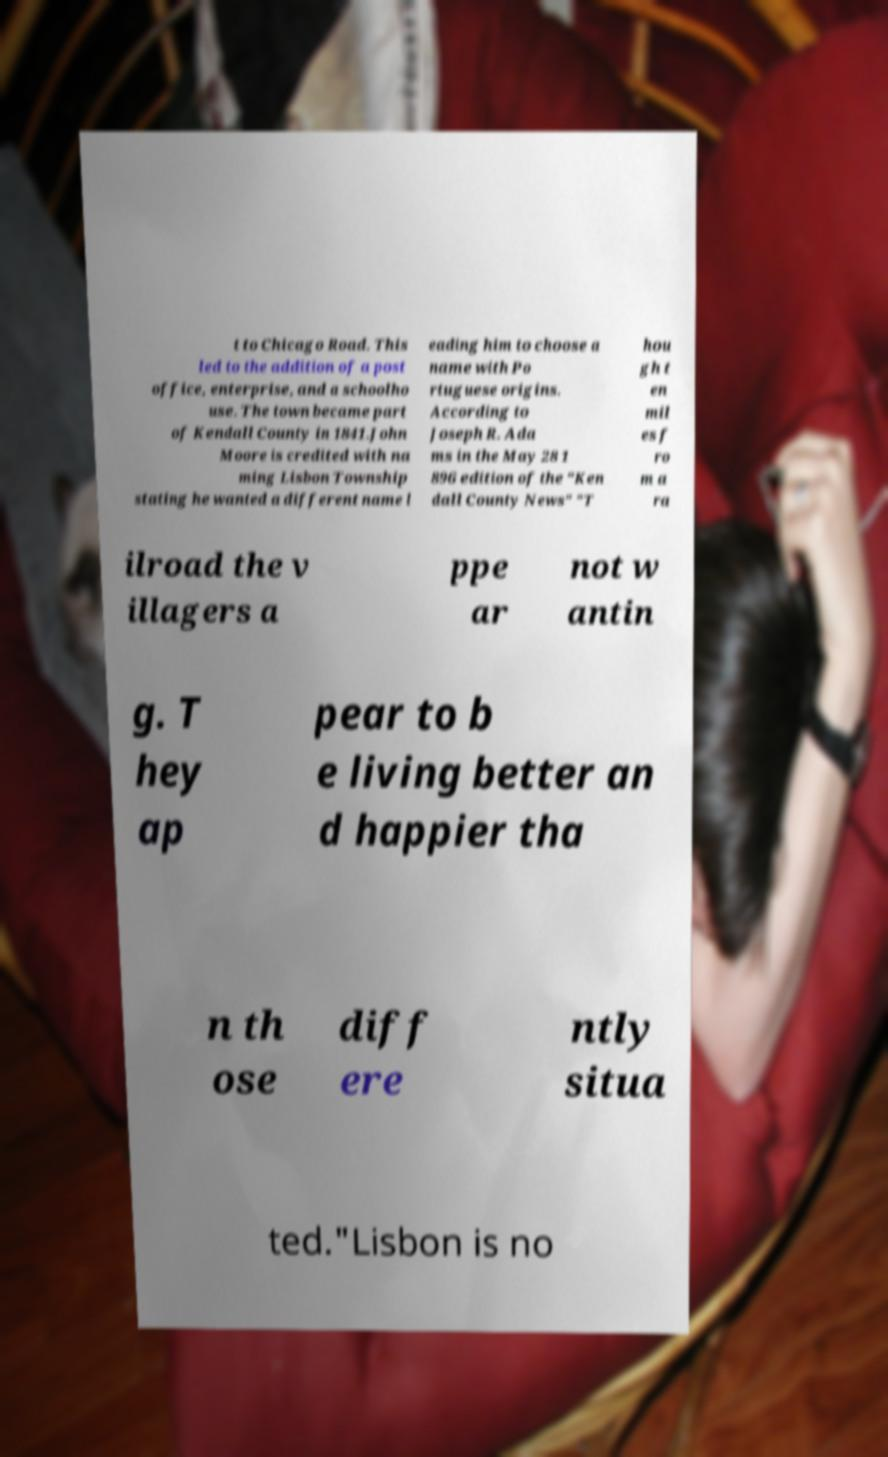What messages or text are displayed in this image? I need them in a readable, typed format. t to Chicago Road. This led to the addition of a post office, enterprise, and a schoolho use. The town became part of Kendall County in 1841.John Moore is credited with na ming Lisbon Township stating he wanted a different name l eading him to choose a name with Po rtuguese origins. According to Joseph R. Ada ms in the May 28 1 896 edition of the "Ken dall County News" "T hou gh t en mil es f ro m a ra ilroad the v illagers a ppe ar not w antin g. T hey ap pear to b e living better an d happier tha n th ose diff ere ntly situa ted."Lisbon is no 